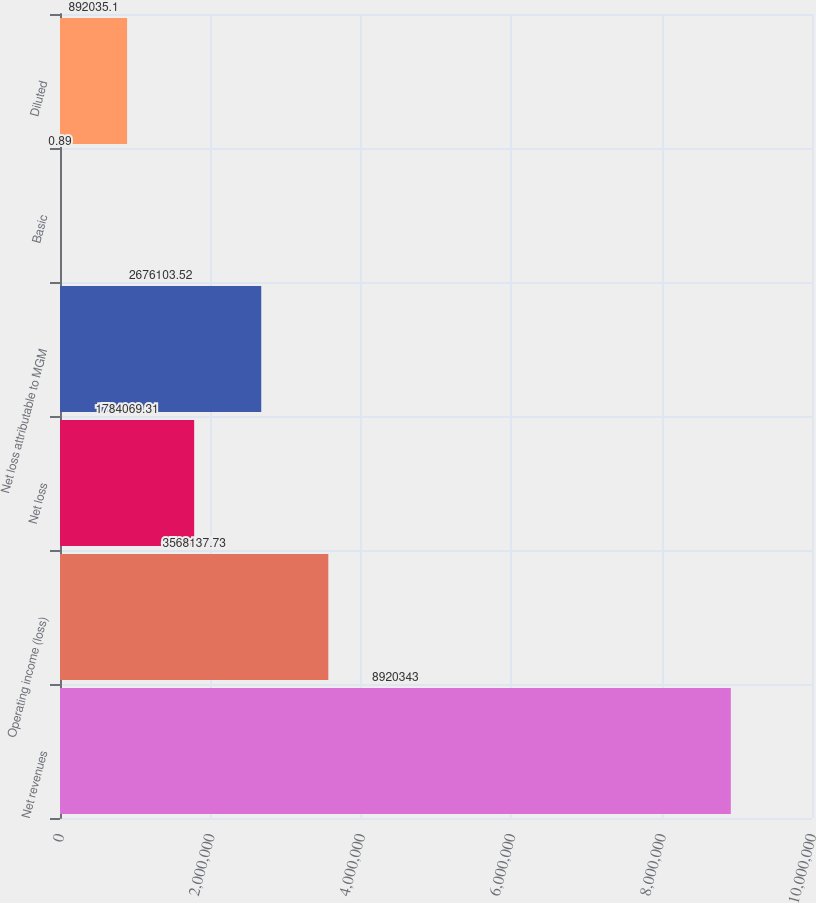Convert chart to OTSL. <chart><loc_0><loc_0><loc_500><loc_500><bar_chart><fcel>Net revenues<fcel>Operating income (loss)<fcel>Net loss<fcel>Net loss attributable to MGM<fcel>Basic<fcel>Diluted<nl><fcel>8.92034e+06<fcel>3.56814e+06<fcel>1.78407e+06<fcel>2.6761e+06<fcel>0.89<fcel>892035<nl></chart> 